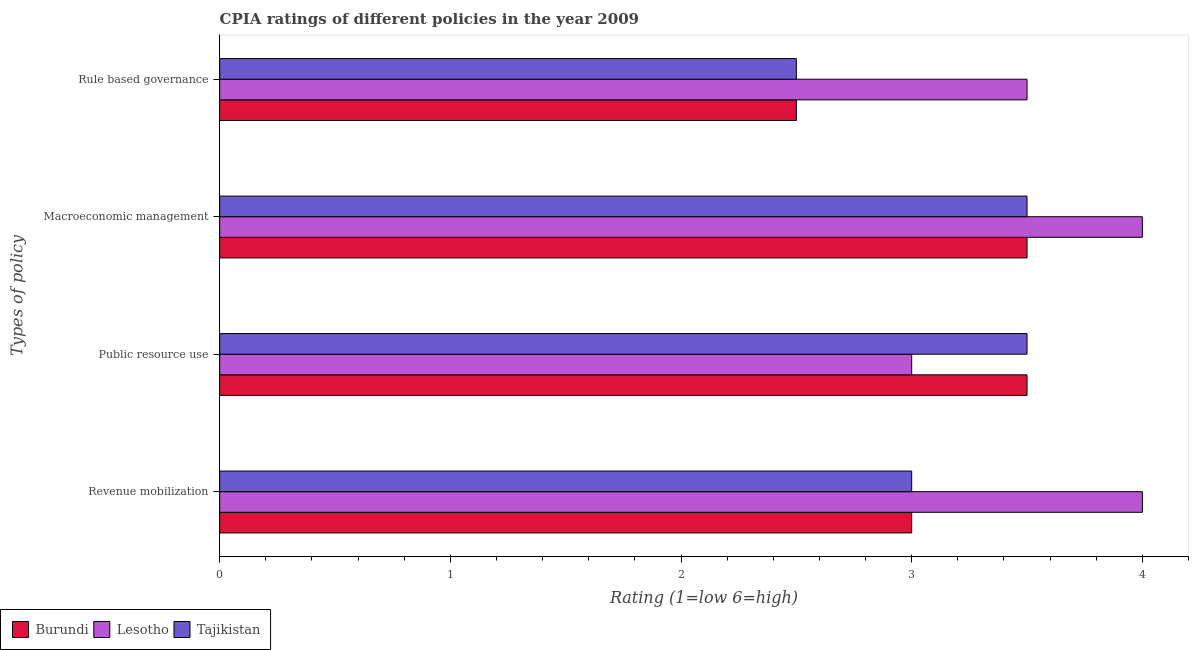How many groups of bars are there?
Your answer should be very brief. 4. How many bars are there on the 2nd tick from the top?
Your response must be concise. 3. How many bars are there on the 3rd tick from the bottom?
Keep it short and to the point. 3. What is the label of the 3rd group of bars from the top?
Give a very brief answer. Public resource use. What is the cpia rating of revenue mobilization in Lesotho?
Keep it short and to the point. 4. Across all countries, what is the maximum cpia rating of macroeconomic management?
Offer a very short reply. 4. Across all countries, what is the minimum cpia rating of macroeconomic management?
Ensure brevity in your answer.  3.5. In which country was the cpia rating of macroeconomic management maximum?
Your answer should be compact. Lesotho. In which country was the cpia rating of rule based governance minimum?
Offer a terse response. Burundi. What is the total cpia rating of public resource use in the graph?
Offer a terse response. 10. What is the difference between the cpia rating of revenue mobilization in Tajikistan and that in Lesotho?
Your answer should be very brief. -1. What is the average cpia rating of public resource use per country?
Your answer should be very brief. 3.33. Is the difference between the cpia rating of rule based governance in Tajikistan and Burundi greater than the difference between the cpia rating of public resource use in Tajikistan and Burundi?
Your response must be concise. No. What is the difference between the highest and the second highest cpia rating of revenue mobilization?
Make the answer very short. 1. What is the difference between the highest and the lowest cpia rating of rule based governance?
Your answer should be very brief. 1. What does the 3rd bar from the top in Public resource use represents?
Provide a succinct answer. Burundi. What does the 1st bar from the bottom in Macroeconomic management represents?
Your answer should be very brief. Burundi. How many bars are there?
Keep it short and to the point. 12. How many countries are there in the graph?
Make the answer very short. 3. Does the graph contain grids?
Offer a very short reply. No. Where does the legend appear in the graph?
Give a very brief answer. Bottom left. How many legend labels are there?
Offer a terse response. 3. How are the legend labels stacked?
Provide a succinct answer. Horizontal. What is the title of the graph?
Offer a very short reply. CPIA ratings of different policies in the year 2009. Does "Iraq" appear as one of the legend labels in the graph?
Give a very brief answer. No. What is the label or title of the Y-axis?
Offer a terse response. Types of policy. What is the Rating (1=low 6=high) in Burundi in Revenue mobilization?
Your response must be concise. 3. What is the Rating (1=low 6=high) of Lesotho in Revenue mobilization?
Give a very brief answer. 4. What is the Rating (1=low 6=high) of Lesotho in Macroeconomic management?
Make the answer very short. 4. What is the Rating (1=low 6=high) of Tajikistan in Macroeconomic management?
Offer a very short reply. 3.5. What is the Rating (1=low 6=high) of Burundi in Rule based governance?
Give a very brief answer. 2.5. What is the Rating (1=low 6=high) of Lesotho in Rule based governance?
Keep it short and to the point. 3.5. What is the Rating (1=low 6=high) in Tajikistan in Rule based governance?
Provide a short and direct response. 2.5. Across all Types of policy, what is the maximum Rating (1=low 6=high) in Lesotho?
Your answer should be compact. 4. Across all Types of policy, what is the maximum Rating (1=low 6=high) of Tajikistan?
Provide a short and direct response. 3.5. Across all Types of policy, what is the minimum Rating (1=low 6=high) of Burundi?
Your answer should be very brief. 2.5. Across all Types of policy, what is the minimum Rating (1=low 6=high) of Lesotho?
Keep it short and to the point. 3. Across all Types of policy, what is the minimum Rating (1=low 6=high) in Tajikistan?
Keep it short and to the point. 2.5. What is the difference between the Rating (1=low 6=high) of Burundi in Revenue mobilization and that in Public resource use?
Your answer should be very brief. -0.5. What is the difference between the Rating (1=low 6=high) in Tajikistan in Revenue mobilization and that in Public resource use?
Provide a succinct answer. -0.5. What is the difference between the Rating (1=low 6=high) of Lesotho in Revenue mobilization and that in Macroeconomic management?
Your answer should be compact. 0. What is the difference between the Rating (1=low 6=high) in Tajikistan in Revenue mobilization and that in Macroeconomic management?
Give a very brief answer. -0.5. What is the difference between the Rating (1=low 6=high) of Burundi in Revenue mobilization and that in Rule based governance?
Make the answer very short. 0.5. What is the difference between the Rating (1=low 6=high) in Lesotho in Revenue mobilization and that in Rule based governance?
Offer a very short reply. 0.5. What is the difference between the Rating (1=low 6=high) of Tajikistan in Revenue mobilization and that in Rule based governance?
Give a very brief answer. 0.5. What is the difference between the Rating (1=low 6=high) in Burundi in Public resource use and that in Macroeconomic management?
Ensure brevity in your answer.  0. What is the difference between the Rating (1=low 6=high) in Tajikistan in Public resource use and that in Macroeconomic management?
Provide a short and direct response. 0. What is the difference between the Rating (1=low 6=high) of Burundi in Public resource use and that in Rule based governance?
Keep it short and to the point. 1. What is the difference between the Rating (1=low 6=high) of Lesotho in Public resource use and that in Rule based governance?
Ensure brevity in your answer.  -0.5. What is the difference between the Rating (1=low 6=high) of Burundi in Revenue mobilization and the Rating (1=low 6=high) of Lesotho in Macroeconomic management?
Keep it short and to the point. -1. What is the difference between the Rating (1=low 6=high) of Burundi in Revenue mobilization and the Rating (1=low 6=high) of Lesotho in Rule based governance?
Provide a succinct answer. -0.5. What is the difference between the Rating (1=low 6=high) of Burundi in Revenue mobilization and the Rating (1=low 6=high) of Tajikistan in Rule based governance?
Offer a very short reply. 0.5. What is the difference between the Rating (1=low 6=high) in Burundi in Public resource use and the Rating (1=low 6=high) in Lesotho in Macroeconomic management?
Ensure brevity in your answer.  -0.5. What is the difference between the Rating (1=low 6=high) in Lesotho in Public resource use and the Rating (1=low 6=high) in Tajikistan in Macroeconomic management?
Offer a very short reply. -0.5. What is the difference between the Rating (1=low 6=high) in Burundi in Public resource use and the Rating (1=low 6=high) in Lesotho in Rule based governance?
Provide a short and direct response. 0. What is the difference between the Rating (1=low 6=high) in Lesotho in Public resource use and the Rating (1=low 6=high) in Tajikistan in Rule based governance?
Provide a short and direct response. 0.5. What is the difference between the Rating (1=low 6=high) in Lesotho in Macroeconomic management and the Rating (1=low 6=high) in Tajikistan in Rule based governance?
Keep it short and to the point. 1.5. What is the average Rating (1=low 6=high) of Burundi per Types of policy?
Your response must be concise. 3.12. What is the average Rating (1=low 6=high) of Lesotho per Types of policy?
Your answer should be very brief. 3.62. What is the average Rating (1=low 6=high) of Tajikistan per Types of policy?
Provide a succinct answer. 3.12. What is the difference between the Rating (1=low 6=high) in Burundi and Rating (1=low 6=high) in Lesotho in Revenue mobilization?
Provide a short and direct response. -1. What is the difference between the Rating (1=low 6=high) in Lesotho and Rating (1=low 6=high) in Tajikistan in Revenue mobilization?
Your answer should be compact. 1. What is the difference between the Rating (1=low 6=high) of Lesotho and Rating (1=low 6=high) of Tajikistan in Public resource use?
Provide a short and direct response. -0.5. What is the difference between the Rating (1=low 6=high) in Burundi and Rating (1=low 6=high) in Tajikistan in Macroeconomic management?
Provide a succinct answer. 0. What is the difference between the Rating (1=low 6=high) of Burundi and Rating (1=low 6=high) of Lesotho in Rule based governance?
Ensure brevity in your answer.  -1. What is the difference between the Rating (1=low 6=high) in Burundi and Rating (1=low 6=high) in Tajikistan in Rule based governance?
Provide a short and direct response. 0. What is the difference between the Rating (1=low 6=high) of Lesotho and Rating (1=low 6=high) of Tajikistan in Rule based governance?
Provide a short and direct response. 1. What is the ratio of the Rating (1=low 6=high) of Lesotho in Revenue mobilization to that in Public resource use?
Keep it short and to the point. 1.33. What is the ratio of the Rating (1=low 6=high) of Tajikistan in Revenue mobilization to that in Public resource use?
Make the answer very short. 0.86. What is the ratio of the Rating (1=low 6=high) of Lesotho in Revenue mobilization to that in Macroeconomic management?
Provide a succinct answer. 1. What is the ratio of the Rating (1=low 6=high) in Tajikistan in Revenue mobilization to that in Macroeconomic management?
Your answer should be very brief. 0.86. What is the ratio of the Rating (1=low 6=high) in Burundi in Revenue mobilization to that in Rule based governance?
Provide a succinct answer. 1.2. What is the ratio of the Rating (1=low 6=high) in Burundi in Public resource use to that in Rule based governance?
Your answer should be compact. 1.4. What is the ratio of the Rating (1=low 6=high) in Lesotho in Public resource use to that in Rule based governance?
Your answer should be very brief. 0.86. What is the ratio of the Rating (1=low 6=high) in Lesotho in Macroeconomic management to that in Rule based governance?
Provide a short and direct response. 1.14. What is the difference between the highest and the second highest Rating (1=low 6=high) in Lesotho?
Your response must be concise. 0. What is the difference between the highest and the lowest Rating (1=low 6=high) in Lesotho?
Keep it short and to the point. 1. 